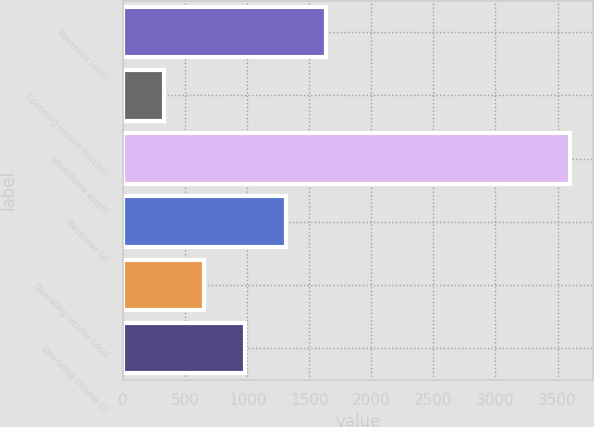<chart> <loc_0><loc_0><loc_500><loc_500><bar_chart><fcel>Revenues (a)(b)<fcel>Operating income (b)(c)(d)<fcel>Identifiable assets<fcel>Revenues (a)<fcel>Operating income (loss)<fcel>Operating income (c)<nl><fcel>1638.4<fcel>328<fcel>3604<fcel>1310.8<fcel>655.6<fcel>983.2<nl></chart> 